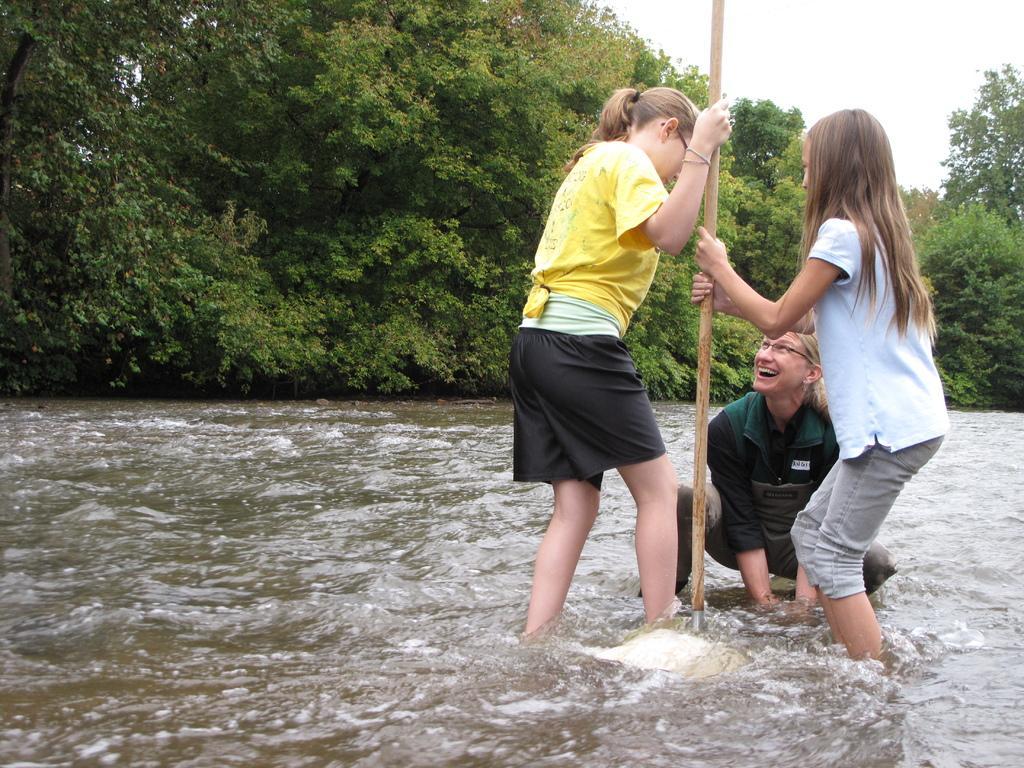Can you describe this image briefly? In this picture, we can see a few people in water, and among them a few are holding an object, we can see trees, and the sky. 